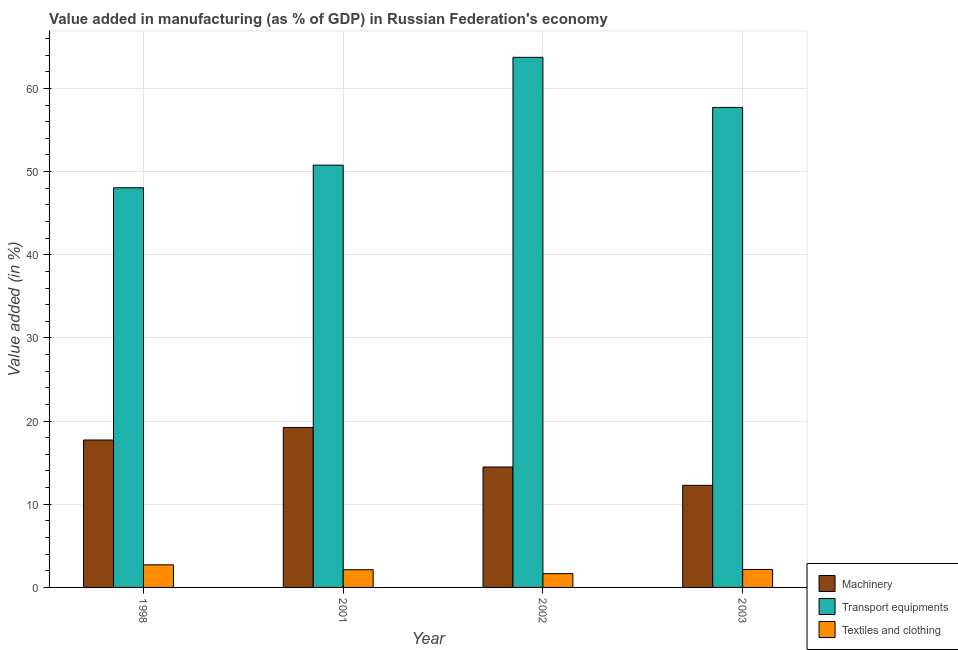How many different coloured bars are there?
Make the answer very short. 3. How many groups of bars are there?
Offer a terse response. 4. Are the number of bars on each tick of the X-axis equal?
Ensure brevity in your answer.  Yes. How many bars are there on the 2nd tick from the left?
Offer a very short reply. 3. What is the label of the 3rd group of bars from the left?
Offer a very short reply. 2002. What is the value added in manufacturing textile and clothing in 1998?
Offer a terse response. 2.72. Across all years, what is the maximum value added in manufacturing transport equipments?
Provide a short and direct response. 63.73. Across all years, what is the minimum value added in manufacturing textile and clothing?
Your response must be concise. 1.66. In which year was the value added in manufacturing textile and clothing minimum?
Give a very brief answer. 2002. What is the total value added in manufacturing machinery in the graph?
Give a very brief answer. 63.71. What is the difference between the value added in manufacturing textile and clothing in 1998 and that in 2003?
Your answer should be very brief. 0.56. What is the difference between the value added in manufacturing textile and clothing in 1998 and the value added in manufacturing machinery in 2002?
Your answer should be very brief. 1.06. What is the average value added in manufacturing transport equipments per year?
Offer a very short reply. 55.07. What is the ratio of the value added in manufacturing textile and clothing in 2001 to that in 2002?
Provide a short and direct response. 1.28. Is the value added in manufacturing machinery in 1998 less than that in 2001?
Offer a very short reply. Yes. What is the difference between the highest and the second highest value added in manufacturing machinery?
Your answer should be very brief. 1.51. What is the difference between the highest and the lowest value added in manufacturing machinery?
Give a very brief answer. 6.96. In how many years, is the value added in manufacturing machinery greater than the average value added in manufacturing machinery taken over all years?
Provide a succinct answer. 2. Is the sum of the value added in manufacturing textile and clothing in 1998 and 2003 greater than the maximum value added in manufacturing transport equipments across all years?
Make the answer very short. Yes. What does the 1st bar from the left in 2001 represents?
Ensure brevity in your answer.  Machinery. What does the 1st bar from the right in 2002 represents?
Keep it short and to the point. Textiles and clothing. Is it the case that in every year, the sum of the value added in manufacturing machinery and value added in manufacturing transport equipments is greater than the value added in manufacturing textile and clothing?
Ensure brevity in your answer.  Yes. How many years are there in the graph?
Ensure brevity in your answer.  4. What is the difference between two consecutive major ticks on the Y-axis?
Provide a succinct answer. 10. Does the graph contain grids?
Provide a succinct answer. Yes. How are the legend labels stacked?
Provide a succinct answer. Vertical. What is the title of the graph?
Ensure brevity in your answer.  Value added in manufacturing (as % of GDP) in Russian Federation's economy. Does "Nuclear sources" appear as one of the legend labels in the graph?
Make the answer very short. No. What is the label or title of the X-axis?
Make the answer very short. Year. What is the label or title of the Y-axis?
Keep it short and to the point. Value added (in %). What is the Value added (in %) of Machinery in 1998?
Your answer should be very brief. 17.73. What is the Value added (in %) in Transport equipments in 1998?
Your answer should be very brief. 48.05. What is the Value added (in %) of Textiles and clothing in 1998?
Keep it short and to the point. 2.72. What is the Value added (in %) of Machinery in 2001?
Your response must be concise. 19.23. What is the Value added (in %) of Transport equipments in 2001?
Ensure brevity in your answer.  50.77. What is the Value added (in %) in Textiles and clothing in 2001?
Your answer should be compact. 2.13. What is the Value added (in %) in Machinery in 2002?
Your answer should be compact. 14.48. What is the Value added (in %) of Transport equipments in 2002?
Your answer should be compact. 63.73. What is the Value added (in %) of Textiles and clothing in 2002?
Provide a short and direct response. 1.66. What is the Value added (in %) of Machinery in 2003?
Offer a terse response. 12.28. What is the Value added (in %) in Transport equipments in 2003?
Ensure brevity in your answer.  57.71. What is the Value added (in %) in Textiles and clothing in 2003?
Give a very brief answer. 2.16. Across all years, what is the maximum Value added (in %) of Machinery?
Give a very brief answer. 19.23. Across all years, what is the maximum Value added (in %) of Transport equipments?
Your response must be concise. 63.73. Across all years, what is the maximum Value added (in %) in Textiles and clothing?
Your response must be concise. 2.72. Across all years, what is the minimum Value added (in %) in Machinery?
Make the answer very short. 12.28. Across all years, what is the minimum Value added (in %) of Transport equipments?
Your answer should be compact. 48.05. Across all years, what is the minimum Value added (in %) of Textiles and clothing?
Offer a very short reply. 1.66. What is the total Value added (in %) in Machinery in the graph?
Offer a very short reply. 63.71. What is the total Value added (in %) in Transport equipments in the graph?
Provide a short and direct response. 220.27. What is the total Value added (in %) of Textiles and clothing in the graph?
Your answer should be very brief. 8.66. What is the difference between the Value added (in %) in Machinery in 1998 and that in 2001?
Provide a succinct answer. -1.51. What is the difference between the Value added (in %) in Transport equipments in 1998 and that in 2001?
Ensure brevity in your answer.  -2.72. What is the difference between the Value added (in %) of Textiles and clothing in 1998 and that in 2001?
Give a very brief answer. 0.59. What is the difference between the Value added (in %) of Machinery in 1998 and that in 2002?
Offer a very short reply. 3.25. What is the difference between the Value added (in %) of Transport equipments in 1998 and that in 2002?
Keep it short and to the point. -15.68. What is the difference between the Value added (in %) in Textiles and clothing in 1998 and that in 2002?
Make the answer very short. 1.06. What is the difference between the Value added (in %) of Machinery in 1998 and that in 2003?
Offer a very short reply. 5.45. What is the difference between the Value added (in %) of Transport equipments in 1998 and that in 2003?
Keep it short and to the point. -9.66. What is the difference between the Value added (in %) in Textiles and clothing in 1998 and that in 2003?
Provide a succinct answer. 0.56. What is the difference between the Value added (in %) in Machinery in 2001 and that in 2002?
Ensure brevity in your answer.  4.76. What is the difference between the Value added (in %) of Transport equipments in 2001 and that in 2002?
Provide a short and direct response. -12.96. What is the difference between the Value added (in %) in Textiles and clothing in 2001 and that in 2002?
Your response must be concise. 0.47. What is the difference between the Value added (in %) of Machinery in 2001 and that in 2003?
Provide a succinct answer. 6.96. What is the difference between the Value added (in %) in Transport equipments in 2001 and that in 2003?
Your answer should be very brief. -6.94. What is the difference between the Value added (in %) in Textiles and clothing in 2001 and that in 2003?
Your response must be concise. -0.03. What is the difference between the Value added (in %) in Machinery in 2002 and that in 2003?
Give a very brief answer. 2.2. What is the difference between the Value added (in %) of Transport equipments in 2002 and that in 2003?
Make the answer very short. 6.02. What is the difference between the Value added (in %) of Textiles and clothing in 2002 and that in 2003?
Your answer should be compact. -0.5. What is the difference between the Value added (in %) of Machinery in 1998 and the Value added (in %) of Transport equipments in 2001?
Your answer should be compact. -33.05. What is the difference between the Value added (in %) in Machinery in 1998 and the Value added (in %) in Textiles and clothing in 2001?
Ensure brevity in your answer.  15.6. What is the difference between the Value added (in %) in Transport equipments in 1998 and the Value added (in %) in Textiles and clothing in 2001?
Provide a succinct answer. 45.92. What is the difference between the Value added (in %) of Machinery in 1998 and the Value added (in %) of Transport equipments in 2002?
Make the answer very short. -46.01. What is the difference between the Value added (in %) of Machinery in 1998 and the Value added (in %) of Textiles and clothing in 2002?
Provide a short and direct response. 16.07. What is the difference between the Value added (in %) in Transport equipments in 1998 and the Value added (in %) in Textiles and clothing in 2002?
Keep it short and to the point. 46.39. What is the difference between the Value added (in %) of Machinery in 1998 and the Value added (in %) of Transport equipments in 2003?
Your answer should be compact. -39.98. What is the difference between the Value added (in %) of Machinery in 1998 and the Value added (in %) of Textiles and clothing in 2003?
Your answer should be compact. 15.57. What is the difference between the Value added (in %) of Transport equipments in 1998 and the Value added (in %) of Textiles and clothing in 2003?
Provide a short and direct response. 45.89. What is the difference between the Value added (in %) in Machinery in 2001 and the Value added (in %) in Transport equipments in 2002?
Your response must be concise. -44.5. What is the difference between the Value added (in %) of Machinery in 2001 and the Value added (in %) of Textiles and clothing in 2002?
Provide a short and direct response. 17.57. What is the difference between the Value added (in %) of Transport equipments in 2001 and the Value added (in %) of Textiles and clothing in 2002?
Ensure brevity in your answer.  49.11. What is the difference between the Value added (in %) in Machinery in 2001 and the Value added (in %) in Transport equipments in 2003?
Your answer should be compact. -38.48. What is the difference between the Value added (in %) of Machinery in 2001 and the Value added (in %) of Textiles and clothing in 2003?
Keep it short and to the point. 17.08. What is the difference between the Value added (in %) of Transport equipments in 2001 and the Value added (in %) of Textiles and clothing in 2003?
Your answer should be very brief. 48.62. What is the difference between the Value added (in %) in Machinery in 2002 and the Value added (in %) in Transport equipments in 2003?
Offer a terse response. -43.23. What is the difference between the Value added (in %) of Machinery in 2002 and the Value added (in %) of Textiles and clothing in 2003?
Ensure brevity in your answer.  12.32. What is the difference between the Value added (in %) of Transport equipments in 2002 and the Value added (in %) of Textiles and clothing in 2003?
Your response must be concise. 61.58. What is the average Value added (in %) in Machinery per year?
Give a very brief answer. 15.93. What is the average Value added (in %) of Transport equipments per year?
Your answer should be compact. 55.07. What is the average Value added (in %) of Textiles and clothing per year?
Provide a succinct answer. 2.17. In the year 1998, what is the difference between the Value added (in %) of Machinery and Value added (in %) of Transport equipments?
Your answer should be compact. -30.33. In the year 1998, what is the difference between the Value added (in %) in Machinery and Value added (in %) in Textiles and clothing?
Ensure brevity in your answer.  15.01. In the year 1998, what is the difference between the Value added (in %) of Transport equipments and Value added (in %) of Textiles and clothing?
Ensure brevity in your answer.  45.34. In the year 2001, what is the difference between the Value added (in %) in Machinery and Value added (in %) in Transport equipments?
Offer a very short reply. -31.54. In the year 2001, what is the difference between the Value added (in %) in Machinery and Value added (in %) in Textiles and clothing?
Your answer should be very brief. 17.1. In the year 2001, what is the difference between the Value added (in %) in Transport equipments and Value added (in %) in Textiles and clothing?
Provide a short and direct response. 48.64. In the year 2002, what is the difference between the Value added (in %) of Machinery and Value added (in %) of Transport equipments?
Your response must be concise. -49.26. In the year 2002, what is the difference between the Value added (in %) of Machinery and Value added (in %) of Textiles and clothing?
Your response must be concise. 12.82. In the year 2002, what is the difference between the Value added (in %) in Transport equipments and Value added (in %) in Textiles and clothing?
Keep it short and to the point. 62.08. In the year 2003, what is the difference between the Value added (in %) of Machinery and Value added (in %) of Transport equipments?
Ensure brevity in your answer.  -45.43. In the year 2003, what is the difference between the Value added (in %) in Machinery and Value added (in %) in Textiles and clothing?
Ensure brevity in your answer.  10.12. In the year 2003, what is the difference between the Value added (in %) of Transport equipments and Value added (in %) of Textiles and clothing?
Give a very brief answer. 55.55. What is the ratio of the Value added (in %) in Machinery in 1998 to that in 2001?
Provide a succinct answer. 0.92. What is the ratio of the Value added (in %) in Transport equipments in 1998 to that in 2001?
Your answer should be very brief. 0.95. What is the ratio of the Value added (in %) of Textiles and clothing in 1998 to that in 2001?
Give a very brief answer. 1.28. What is the ratio of the Value added (in %) of Machinery in 1998 to that in 2002?
Your response must be concise. 1.22. What is the ratio of the Value added (in %) of Transport equipments in 1998 to that in 2002?
Offer a terse response. 0.75. What is the ratio of the Value added (in %) of Textiles and clothing in 1998 to that in 2002?
Keep it short and to the point. 1.64. What is the ratio of the Value added (in %) of Machinery in 1998 to that in 2003?
Make the answer very short. 1.44. What is the ratio of the Value added (in %) of Transport equipments in 1998 to that in 2003?
Keep it short and to the point. 0.83. What is the ratio of the Value added (in %) in Textiles and clothing in 1998 to that in 2003?
Offer a very short reply. 1.26. What is the ratio of the Value added (in %) of Machinery in 2001 to that in 2002?
Offer a terse response. 1.33. What is the ratio of the Value added (in %) of Transport equipments in 2001 to that in 2002?
Your answer should be compact. 0.8. What is the ratio of the Value added (in %) in Textiles and clothing in 2001 to that in 2002?
Ensure brevity in your answer.  1.28. What is the ratio of the Value added (in %) of Machinery in 2001 to that in 2003?
Offer a terse response. 1.57. What is the ratio of the Value added (in %) of Transport equipments in 2001 to that in 2003?
Make the answer very short. 0.88. What is the ratio of the Value added (in %) of Textiles and clothing in 2001 to that in 2003?
Provide a succinct answer. 0.99. What is the ratio of the Value added (in %) of Machinery in 2002 to that in 2003?
Your answer should be compact. 1.18. What is the ratio of the Value added (in %) of Transport equipments in 2002 to that in 2003?
Offer a terse response. 1.1. What is the ratio of the Value added (in %) in Textiles and clothing in 2002 to that in 2003?
Offer a terse response. 0.77. What is the difference between the highest and the second highest Value added (in %) in Machinery?
Provide a succinct answer. 1.51. What is the difference between the highest and the second highest Value added (in %) in Transport equipments?
Provide a succinct answer. 6.02. What is the difference between the highest and the second highest Value added (in %) of Textiles and clothing?
Your response must be concise. 0.56. What is the difference between the highest and the lowest Value added (in %) in Machinery?
Make the answer very short. 6.96. What is the difference between the highest and the lowest Value added (in %) of Transport equipments?
Keep it short and to the point. 15.68. What is the difference between the highest and the lowest Value added (in %) of Textiles and clothing?
Give a very brief answer. 1.06. 